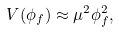<formula> <loc_0><loc_0><loc_500><loc_500>V ( \phi _ { f } ) \approx \mu ^ { 2 } \phi _ { f } ^ { 2 } ,</formula> 